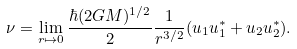Convert formula to latex. <formula><loc_0><loc_0><loc_500><loc_500>\nu = \lim _ { r \mapsto 0 } \frac { \hbar { ( } 2 G M ) ^ { 1 / 2 } } { 2 } \frac { 1 } { r ^ { 3 / 2 } } ( u _ { 1 } u _ { 1 } ^ { \ast } + u _ { 2 } u _ { 2 } ^ { \ast } ) .</formula> 